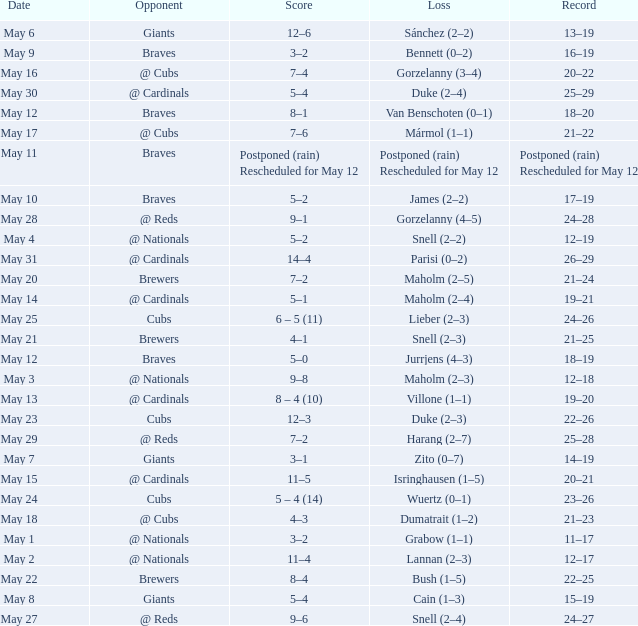Who was the opponent at the game with a score of 7–6? @ Cubs. 